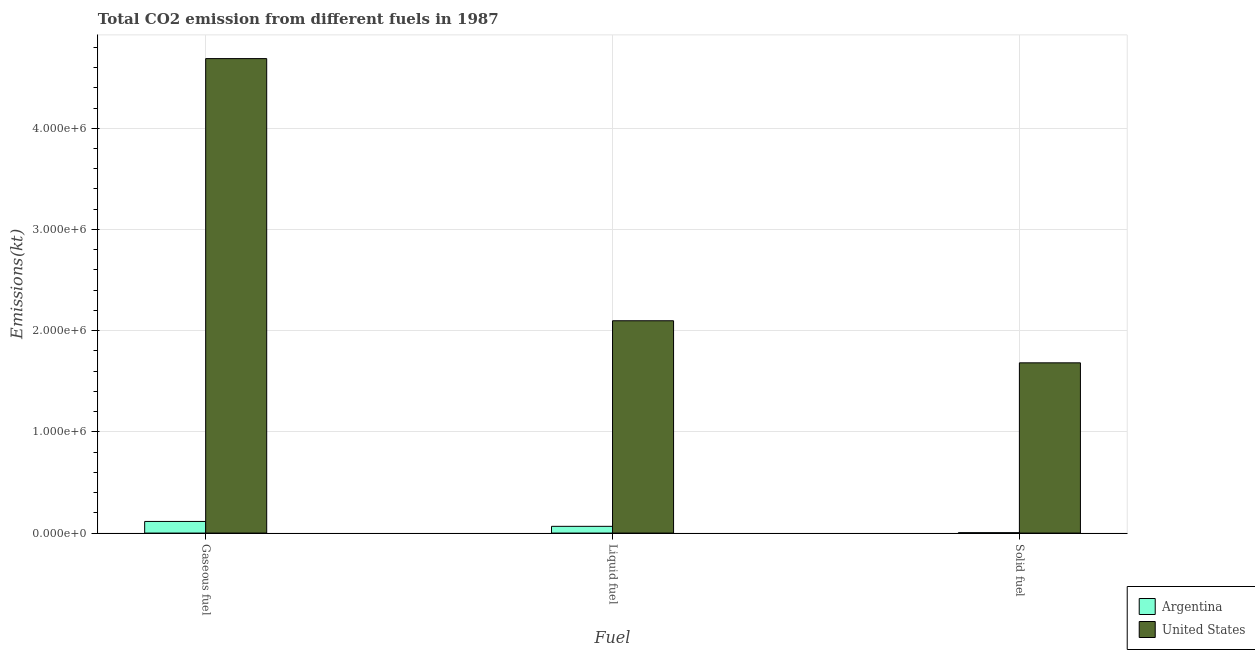How many different coloured bars are there?
Make the answer very short. 2. How many groups of bars are there?
Provide a short and direct response. 3. What is the label of the 2nd group of bars from the left?
Provide a succinct answer. Liquid fuel. What is the amount of co2 emissions from solid fuel in United States?
Offer a very short reply. 1.68e+06. Across all countries, what is the maximum amount of co2 emissions from gaseous fuel?
Provide a succinct answer. 4.69e+06. Across all countries, what is the minimum amount of co2 emissions from solid fuel?
Provide a succinct answer. 3780.68. In which country was the amount of co2 emissions from gaseous fuel maximum?
Make the answer very short. United States. What is the total amount of co2 emissions from solid fuel in the graph?
Your response must be concise. 1.69e+06. What is the difference between the amount of co2 emissions from liquid fuel in United States and that in Argentina?
Give a very brief answer. 2.03e+06. What is the difference between the amount of co2 emissions from solid fuel in Argentina and the amount of co2 emissions from liquid fuel in United States?
Your answer should be compact. -2.09e+06. What is the average amount of co2 emissions from liquid fuel per country?
Your answer should be compact. 1.08e+06. What is the difference between the amount of co2 emissions from liquid fuel and amount of co2 emissions from solid fuel in United States?
Provide a short and direct response. 4.16e+05. In how many countries, is the amount of co2 emissions from gaseous fuel greater than 3000000 kt?
Make the answer very short. 1. What is the ratio of the amount of co2 emissions from solid fuel in Argentina to that in United States?
Offer a very short reply. 0. Is the difference between the amount of co2 emissions from liquid fuel in Argentina and United States greater than the difference between the amount of co2 emissions from solid fuel in Argentina and United States?
Provide a short and direct response. No. What is the difference between the highest and the second highest amount of co2 emissions from gaseous fuel?
Provide a succinct answer. 4.57e+06. What is the difference between the highest and the lowest amount of co2 emissions from gaseous fuel?
Your answer should be compact. 4.57e+06. In how many countries, is the amount of co2 emissions from solid fuel greater than the average amount of co2 emissions from solid fuel taken over all countries?
Provide a succinct answer. 1. How many bars are there?
Provide a short and direct response. 6. What is the difference between two consecutive major ticks on the Y-axis?
Make the answer very short. 1.00e+06. Are the values on the major ticks of Y-axis written in scientific E-notation?
Keep it short and to the point. Yes. Does the graph contain grids?
Provide a succinct answer. Yes. How many legend labels are there?
Provide a short and direct response. 2. How are the legend labels stacked?
Ensure brevity in your answer.  Vertical. What is the title of the graph?
Provide a short and direct response. Total CO2 emission from different fuels in 1987. What is the label or title of the X-axis?
Your answer should be compact. Fuel. What is the label or title of the Y-axis?
Provide a short and direct response. Emissions(kt). What is the Emissions(kt) in Argentina in Gaseous fuel?
Ensure brevity in your answer.  1.15e+05. What is the Emissions(kt) in United States in Gaseous fuel?
Offer a terse response. 4.69e+06. What is the Emissions(kt) in Argentina in Liquid fuel?
Your answer should be compact. 6.65e+04. What is the Emissions(kt) in United States in Liquid fuel?
Offer a terse response. 2.10e+06. What is the Emissions(kt) of Argentina in Solid fuel?
Your response must be concise. 3780.68. What is the Emissions(kt) of United States in Solid fuel?
Provide a short and direct response. 1.68e+06. Across all Fuel, what is the maximum Emissions(kt) of Argentina?
Keep it short and to the point. 1.15e+05. Across all Fuel, what is the maximum Emissions(kt) in United States?
Your answer should be compact. 4.69e+06. Across all Fuel, what is the minimum Emissions(kt) in Argentina?
Provide a succinct answer. 3780.68. Across all Fuel, what is the minimum Emissions(kt) of United States?
Give a very brief answer. 1.68e+06. What is the total Emissions(kt) in Argentina in the graph?
Keep it short and to the point. 1.85e+05. What is the total Emissions(kt) of United States in the graph?
Make the answer very short. 8.47e+06. What is the difference between the Emissions(kt) in Argentina in Gaseous fuel and that in Liquid fuel?
Your response must be concise. 4.84e+04. What is the difference between the Emissions(kt) in United States in Gaseous fuel and that in Liquid fuel?
Ensure brevity in your answer.  2.59e+06. What is the difference between the Emissions(kt) in Argentina in Gaseous fuel and that in Solid fuel?
Ensure brevity in your answer.  1.11e+05. What is the difference between the Emissions(kt) in United States in Gaseous fuel and that in Solid fuel?
Provide a short and direct response. 3.01e+06. What is the difference between the Emissions(kt) of Argentina in Liquid fuel and that in Solid fuel?
Give a very brief answer. 6.27e+04. What is the difference between the Emissions(kt) of United States in Liquid fuel and that in Solid fuel?
Offer a terse response. 4.16e+05. What is the difference between the Emissions(kt) in Argentina in Gaseous fuel and the Emissions(kt) in United States in Liquid fuel?
Make the answer very short. -1.98e+06. What is the difference between the Emissions(kt) in Argentina in Gaseous fuel and the Emissions(kt) in United States in Solid fuel?
Your answer should be compact. -1.57e+06. What is the difference between the Emissions(kt) of Argentina in Liquid fuel and the Emissions(kt) of United States in Solid fuel?
Provide a succinct answer. -1.62e+06. What is the average Emissions(kt) in Argentina per Fuel?
Provide a succinct answer. 6.17e+04. What is the average Emissions(kt) of United States per Fuel?
Provide a short and direct response. 2.82e+06. What is the difference between the Emissions(kt) in Argentina and Emissions(kt) in United States in Gaseous fuel?
Keep it short and to the point. -4.57e+06. What is the difference between the Emissions(kt) of Argentina and Emissions(kt) of United States in Liquid fuel?
Your answer should be very brief. -2.03e+06. What is the difference between the Emissions(kt) of Argentina and Emissions(kt) of United States in Solid fuel?
Your answer should be compact. -1.68e+06. What is the ratio of the Emissions(kt) of Argentina in Gaseous fuel to that in Liquid fuel?
Keep it short and to the point. 1.73. What is the ratio of the Emissions(kt) in United States in Gaseous fuel to that in Liquid fuel?
Your response must be concise. 2.23. What is the ratio of the Emissions(kt) of Argentina in Gaseous fuel to that in Solid fuel?
Your response must be concise. 30.4. What is the ratio of the Emissions(kt) of United States in Gaseous fuel to that in Solid fuel?
Ensure brevity in your answer.  2.79. What is the ratio of the Emissions(kt) in Argentina in Liquid fuel to that in Solid fuel?
Your response must be concise. 17.59. What is the ratio of the Emissions(kt) of United States in Liquid fuel to that in Solid fuel?
Ensure brevity in your answer.  1.25. What is the difference between the highest and the second highest Emissions(kt) of Argentina?
Provide a succinct answer. 4.84e+04. What is the difference between the highest and the second highest Emissions(kt) of United States?
Ensure brevity in your answer.  2.59e+06. What is the difference between the highest and the lowest Emissions(kt) in Argentina?
Make the answer very short. 1.11e+05. What is the difference between the highest and the lowest Emissions(kt) in United States?
Keep it short and to the point. 3.01e+06. 